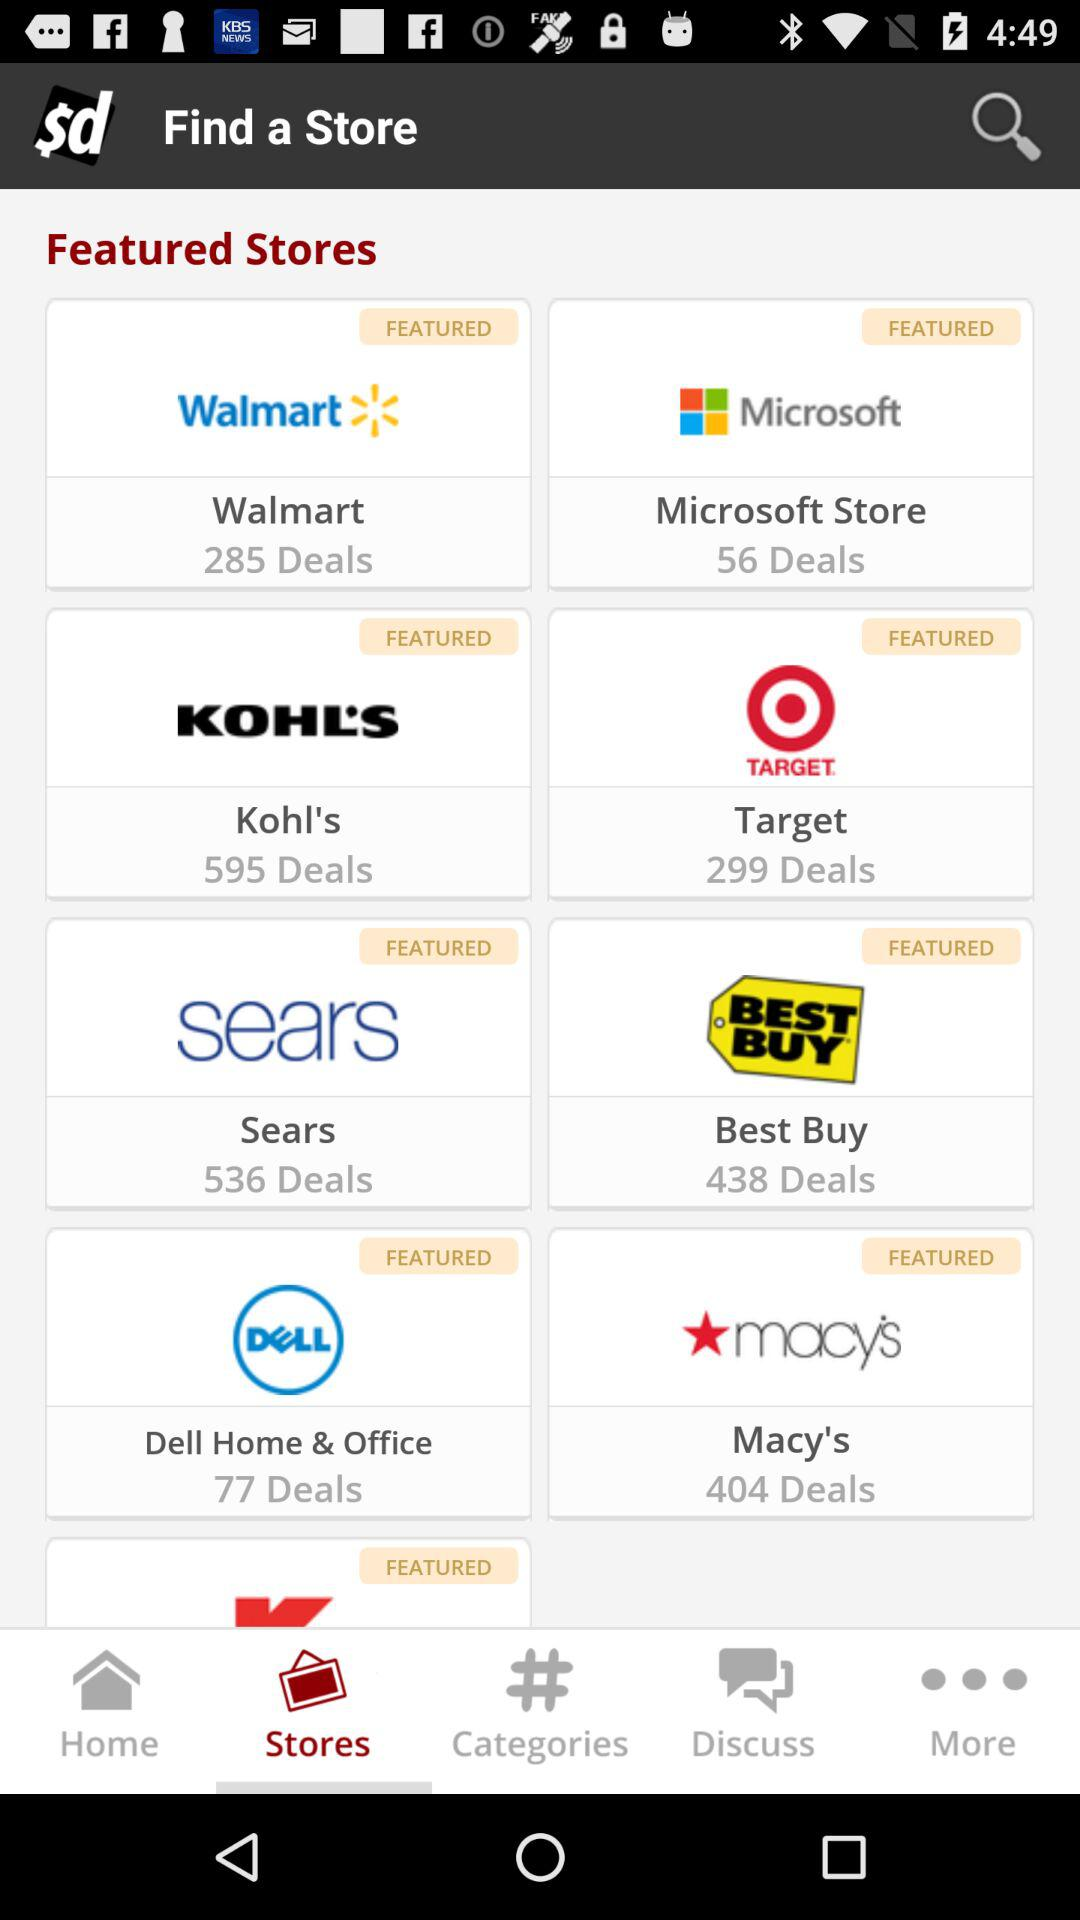How many deals are there on "Dell Home & office"? There are 77 deals on "Dell Home & office". 